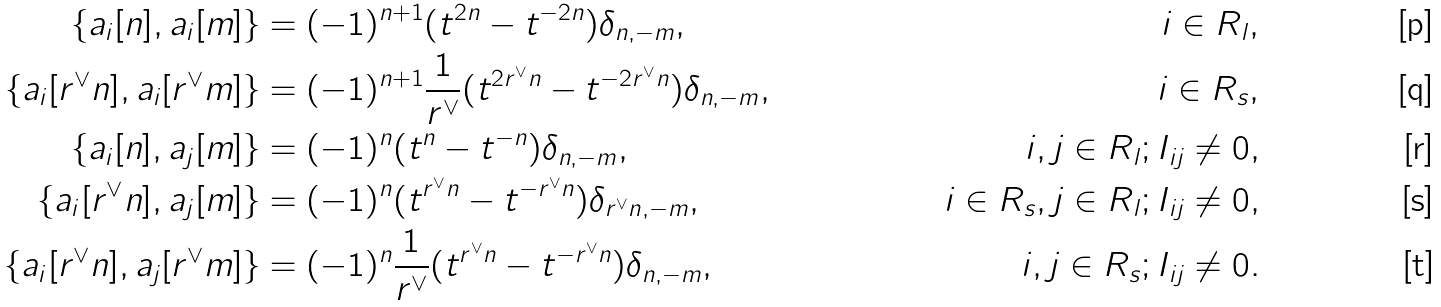Convert formula to latex. <formula><loc_0><loc_0><loc_500><loc_500>\{ a _ { i } [ n ] , a _ { i } [ m ] \} & = ( - 1 ) ^ { n + 1 } ( t ^ { 2 n } - t ^ { - 2 n } ) \delta _ { n , - m } , & i \in R _ { l } , \\ \{ a _ { i } [ r ^ { \vee } n ] , a _ { i } [ r ^ { \vee } m ] \} & = ( - 1 ) ^ { n + 1 } \frac { 1 } { r ^ { \vee } } ( t ^ { 2 r ^ { \vee } n } - t ^ { - 2 r ^ { \vee } n } ) \delta _ { n , - m } , & i \in R _ { s } , \\ \{ a _ { i } [ n ] , a _ { j } [ m ] \} & = ( - 1 ) ^ { n } ( t ^ { n } - t ^ { - n } ) \delta _ { n , - m } , & i , j \in R _ { l } ; I _ { i j } \neq 0 , \\ \{ a _ { i } [ r ^ { \vee } n ] , a _ { j } [ m ] \} & = ( - 1 ) ^ { n } ( t ^ { r ^ { \vee } n } - t ^ { - r ^ { \vee } n } ) \delta _ { r ^ { \vee } n , - m } , & i \in R _ { s } , j \in R _ { l } ; I _ { i j } \neq 0 , \\ \{ a _ { i } [ r ^ { \vee } n ] , a _ { j } [ r ^ { \vee } m ] \} & = ( - 1 ) ^ { n } \frac { 1 } { r ^ { \vee } } ( t ^ { r ^ { \vee } n } - t ^ { - r ^ { \vee } n } ) \delta _ { n , - m } , & i , j \in R _ { s } ; I _ { i j } \neq 0 .</formula> 